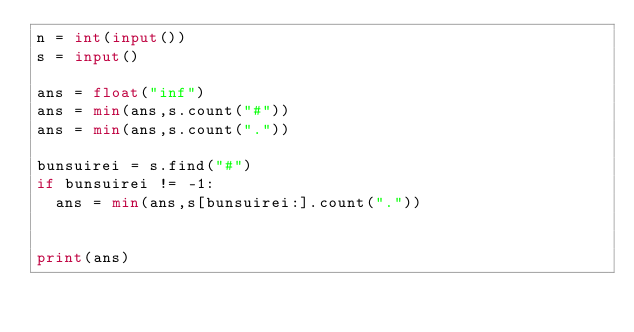Convert code to text. <code><loc_0><loc_0><loc_500><loc_500><_Python_>n = int(input())
s = input()

ans = float("inf")
ans = min(ans,s.count("#"))
ans = min(ans,s.count("."))

bunsuirei = s.find("#")
if bunsuirei != -1:
  ans = min(ans,s[bunsuirei:].count("."))


print(ans)</code> 